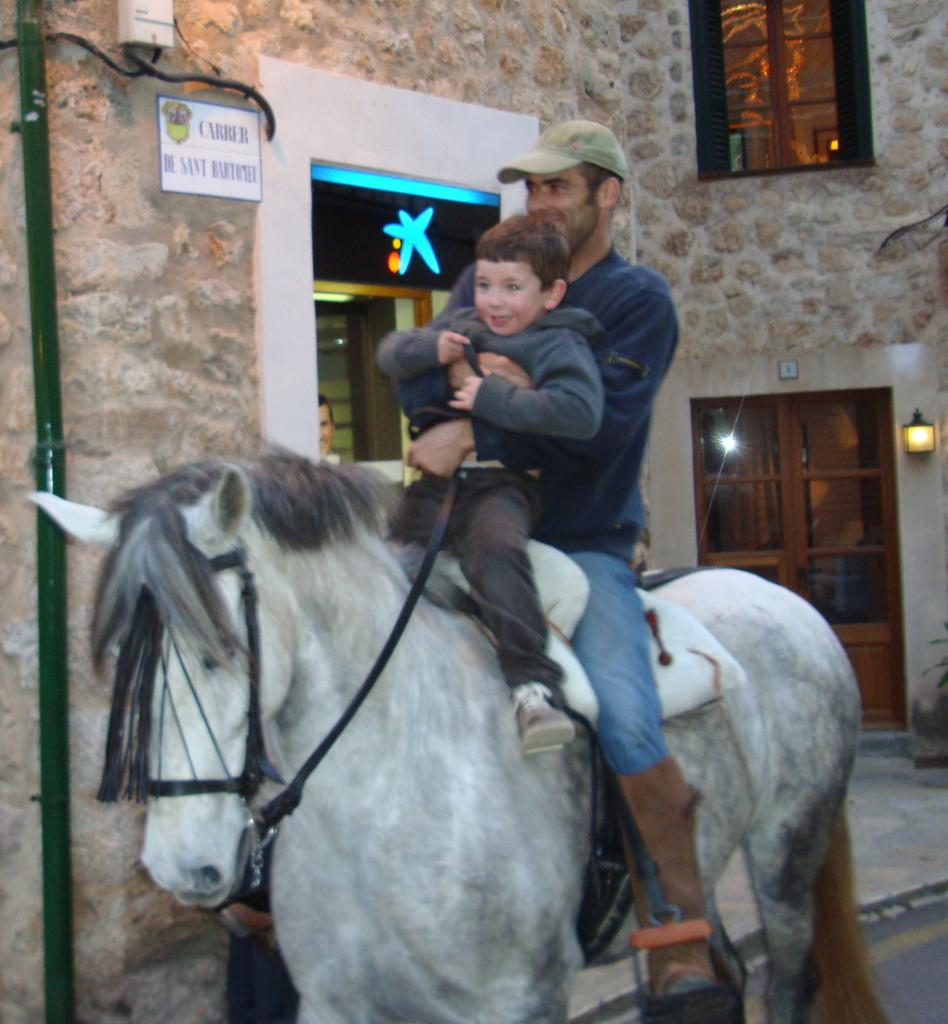Who is present in the image? There is a man and a boy in the image. What are the man and the boy doing in the image? Both the man and the boy are riding a horse. What can be seen in the background of the image? There is a house visible in the image. What type of stitch is being used to mend the horse's saddle in the image? There is no indication in the image that the horse's saddle is being mended or that any stitching is taking place. 